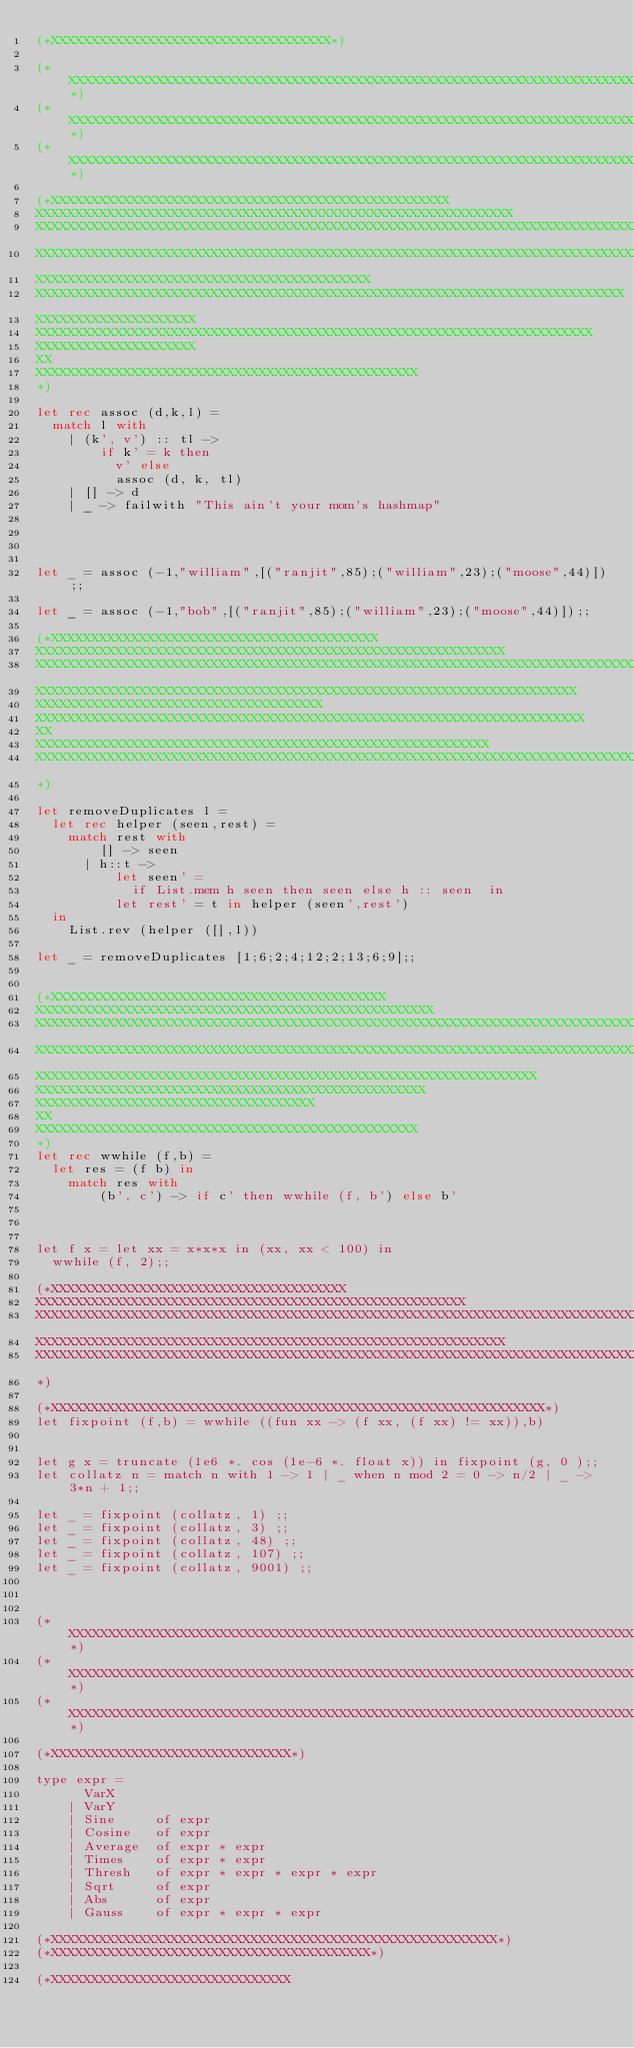<code> <loc_0><loc_0><loc_500><loc_500><_OCaml_>(*XXXXXXXXXXXXXXXXXXXXXXXXXXXXXXXXXXX*)

(*XXXXXXXXXXXXXXXXXXXXXXXXXXXXXXXXXXXXXXXXXXXXXXXXXXXXXXXXXXXXXXXXXXXXXXXXXXXXXXXXXXXXXX*)
(*XXXXXXXXXXXXXXXXXXXXXXXXXXXXXXXXXXXXXXXXXXXXXXXXXXXXXXXXXXXXXXXXXXXXXXXXXXXXXXXXXXXXXX*)
(*XXXXXXXXXXXXXXXXXXXXXXXXXXXXXXXXXXXXXXXXXXXXXXXXXXXXXXXXXXXXXXXXXXXXXXXXXXXXXXXXXXXXXX*)

(*XXXXXXXXXXXXXXXXXXXXXXXXXXXXXXXXXXXXXXXXXXXXXXXXXX
XXXXXXXXXXXXXXXXXXXXXXXXXXXXXXXXXXXXXXXXXXXXXXXXXXXXXXXXXXXX
XXXXXXXXXXXXXXXXXXXXXXXXXXXXXXXXXXXXXXXXXXXXXXXXXXXXXXXXXXXXXXXXXXXXXXXXXXXXXXXXXXX
XXXXXXXXXXXXXXXXXXXXXXXXXXXXXXXXXXXXXXXXXXXXXXXXXXXXXXXXXXXXXXXXXXXXXXXXXXXXXXXXXXXXX
XXXXXXXXXXXXXXXXXXXXXXXXXXXXXXXXXXXXXXXXXX
XXXXXXXXXXXXXXXXXXXXXXXXXXXXXXXXXXXXXXXXXXXXXXXXXXXXXXXXXXXXXXXXXXXXXXXXXX
XXXXXXXXXXXXXXXXXXXX
XXXXXXXXXXXXXXXXXXXXXXXXXXXXXXXXXXXXXXXXXXXXXXXXXXXXXXXXXXXXXXXXXXXXXX
XXXXXXXXXXXXXXXXXXXX
XX
XXXXXXXXXXXXXXXXXXXXXXXXXXXXXXXXXXXXXXXXXXXXXXXX
*)

let rec assoc (d,k,l) = 
  match l with 
    | (k', v') :: tl -> 
        if k' = k then 
          v' else 
          assoc (d, k, tl)
    | [] -> d
    | _ -> failwith "This ain't your mom's hashmap"




let _ = assoc (-1,"william",[("ranjit",85);("william",23);("moose",44)]);;    

let _ = assoc (-1,"bob",[("ranjit",85);("william",23);("moose",44)]);;

(*XXXXXXXXXXXXXXXXXXXXXXXXXXXXXXXXXXXXXXXXX
XXXXXXXXXXXXXXXXXXXXXXXXXXXXXXXXXXXXXXXXXXXXXXXXXXXXXXXXXXX
XXXXXXXXXXXXXXXXXXXXXXXXXXXXXXXXXXXXXXXXXXXXXXXXXXXXXXXXXXXXXXXXXXXXXXXXXXXXX
XXXXXXXXXXXXXXXXXXXXXXXXXXXXXXXXXXXXXXXXXXXXXXXXXXXXXXXXXXXXXXXXXXXX
XXXXXXXXXXXXXXXXXXXXXXXXXXXXXXXXXXXX
XXXXXXXXXXXXXXXXXXXXXXXXXXXXXXXXXXXXXXXXXXXXXXXXXXXXXXXXXXXXXXXXXXXXX
XX
XXXXXXXXXXXXXXXXXXXXXXXXXXXXXXXXXXXXXXXXXXXXXXXXXXXXXXXXX
XXXXXXXXXXXXXXXXXXXXXXXXXXXXXXXXXXXXXXXXXXXXXXXXXXXXXXXXXXXXXXXXXXXXXXXXXXXXXXXX
*)

let removeDuplicates l = 
  let rec helper (seen,rest) = 
    match rest with 
        [] -> seen
      | h::t -> 
          let seen' = 
            if List.mem h seen then seen else h :: seen  in
          let rest' = t in helper (seen',rest') 
  in
    List.rev (helper ([],l))

let _ = removeDuplicates [1;6;2;4;12;2;13;6;9];;


(*XXXXXXXXXXXXXXXXXXXXXXXXXXXXXXXXXXXXXXXXXX
XXXXXXXXXXXXXXXXXXXXXXXXXXXXXXXXXXXXXXXXXXXXXXXXXX
XXXXXXXXXXXXXXXXXXXXXXXXXXXXXXXXXXXXXXXXXXXXXXXXXXXXXXXXXXXXXXXXXXXXXXXXXXXXX
XXXXXXXXXXXXXXXXXXXXXXXXXXXXXXXXXXXXXXXXXXXXXXXXXXXXXXXXXXXXXXXXXXXXXXXXXXXXXXXXXXXX
XXXXXXXXXXXXXXXXXXXXXXXXXXXXXXXXXXXXXXXXXXXXXXXXXXXXXXXXXXXXXXX
XXXXXXXXXXXXXXXXXXXXXXXXXXXXXXXXXXXXXXXXXXXXXXXXX
XXXXXXXXXXXXXXXXXXXXXXXXXXXXXXXXXXX
XX
XXXXXXXXXXXXXXXXXXXXXXXXXXXXXXXXXXXXXXXXXXXXXXXX
*)
let rec wwhile (f,b) =
  let res = (f b) in
    match res with
        (b', c') -> if c' then wwhile (f, b') else b'



let f x = let xx = x*x*x in (xx, xx < 100) in
  wwhile (f, 2);;

(*XXXXXXXXXXXXXXXXXXXXXXXXXXXXXXXXXXXXX
XXXXXXXXXXXXXXXXXXXXXXXXXXXXXXXXXXXXXXXXXXXXXXXXXXXXXX
XXXXXXXXXXXXXXXXXXXXXXXXXXXXXXXXXXXXXXXXXXXXXXXXXXXXXXXXXXXXXXXXXXXXXXXXXXXXXXXXX
XXXXXXXXXXXXXXXXXXXXXXXXXXXXXXXXXXXXXXXXXXXXXXXXXXXXXXXXXXX
XXXXXXXXXXXXXXXXXXXXXXXXXXXXXXXXXXXXXXXXXXXXXXXXXXXXXXXXXXXXXXXXXXXXXXXXXXXXXXXXXXXXXXXXXXXXXXXXXXXX
*)

(*XXXXXXXXXXXXXXXXXXXXXXXXXXXXXXXXXXXXXXXXXXXXXXXXXXXXXXXXXXXXXX*)
let fixpoint (f,b) = wwhile ((fun xx -> (f xx, (f xx) != xx)),b)


let g x = truncate (1e6 *. cos (1e-6 *. float x)) in fixpoint (g, 0 );; 
let collatz n = match n with 1 -> 1 | _ when n mod 2 = 0 -> n/2 | _ -> 3*n + 1;;

let _ = fixpoint (collatz, 1) ;;
let _ = fixpoint (collatz, 3) ;;
let _ = fixpoint (collatz, 48) ;;
let _ = fixpoint (collatz, 107) ;;
let _ = fixpoint (collatz, 9001) ;;



(*XXXXXXXXXXXXXXXXXXXXXXXXXXXXXXXXXXXXXXXXXXXXXXXXXXXXXXXXXXXXXXXXXXXXXXXXXXXXXXXXXXXXXX*)
(*XXXXXXXXXXXXXXXXXXXXXXXXXXXXXXXXXXXXXXXXXXXXXXXXXXXXXXXXXXXXXXXXXXXXXXXXXXXXXXXXXXXXXX*)
(*XXXXXXXXXXXXXXXXXXXXXXXXXXXXXXXXXXXXXXXXXXXXXXXXXXXXXXXXXXXXXXXXXXXXXXXXXXXXXXXXXXXXXX*)

(*XXXXXXXXXXXXXXXXXXXXXXXXXXXXXX*) 

type expr = 
      VarX
    | VarY
    | Sine     of expr
    | Cosine   of expr
    | Average  of expr * expr
    | Times    of expr * expr
    | Thresh   of expr * expr * expr * expr	
    | Sqrt     of expr
    | Abs      of expr
    | Gauss    of expr * expr * expr

(*XXXXXXXXXXXXXXXXXXXXXXXXXXXXXXXXXXXXXXXXXXXXXXXXXXXXXXXX*)
(*XXXXXXXXXXXXXXXXXXXXXXXXXXXXXXXXXXXXXXXX*)

(*XXXXXXXXXXXXXXXXXXXXXXXXXXXXXX</code> 